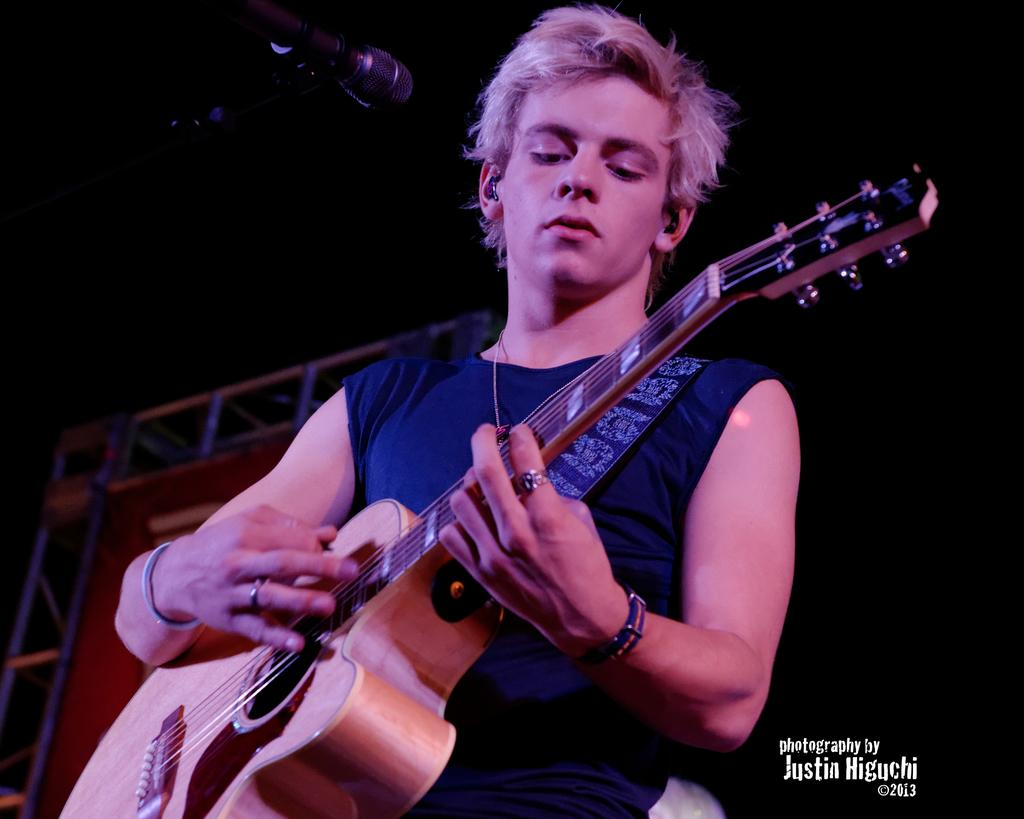Who is the main subject in the image? There is a man in the image. What is the man doing in the image? The man is playing a guitar. What object is in front of the man? There is a microphone in front of the man. Can you tell me how many boats are docked at the harbor in the image? There is no harbor or boats present in the image; it features a man playing a guitar with a microphone in front of him. What type of drink is the man holding in the image? There is no drink visible in the image; the man is holding a guitar. 